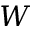Convert formula to latex. <formula><loc_0><loc_0><loc_500><loc_500>\boldsymbol W</formula> 